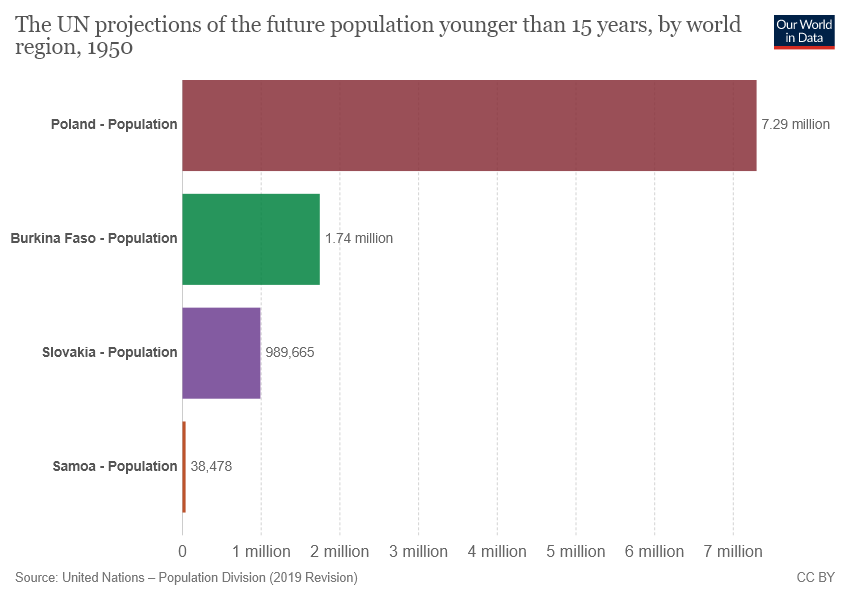Indicate a few pertinent items in this graphic. The value of the upper bound of the 95% confidence interval for the mean of a normal distribution with a mean of 7.29 is 7.29. 